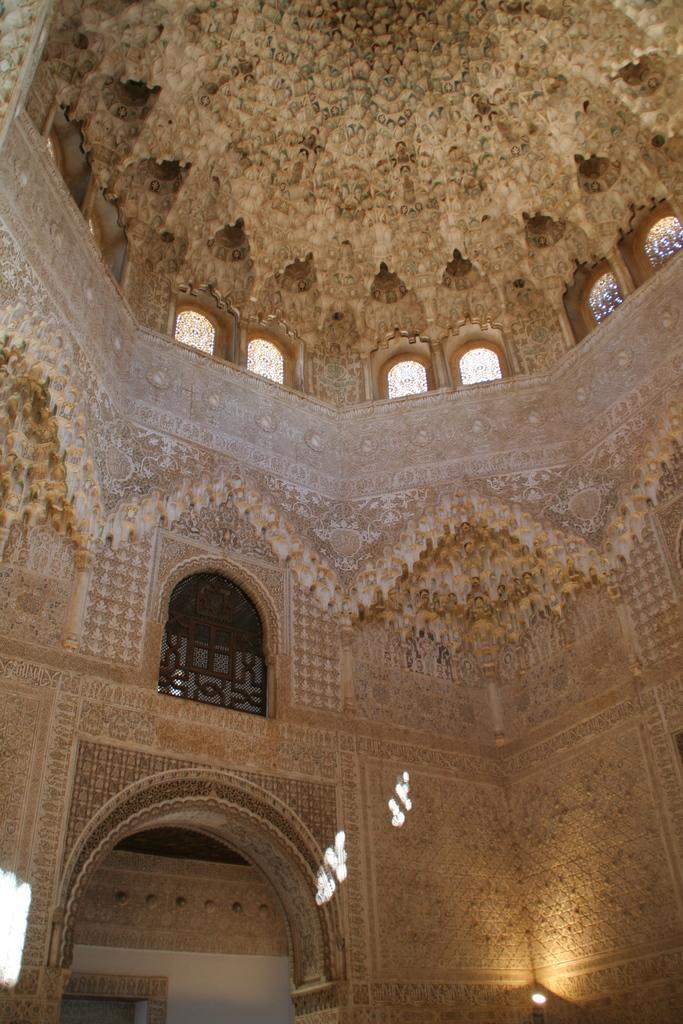In one or two sentences, can you explain what this image depicts? In the image there is an arch in the foreground and around the arch there are beautiful carvings and windows to the walls inside an architecture. 